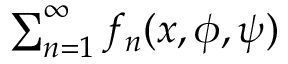<formula> <loc_0><loc_0><loc_500><loc_500>\sum _ { n = 1 } ^ { \infty } f _ { n } ( x , \phi , \psi )</formula> 